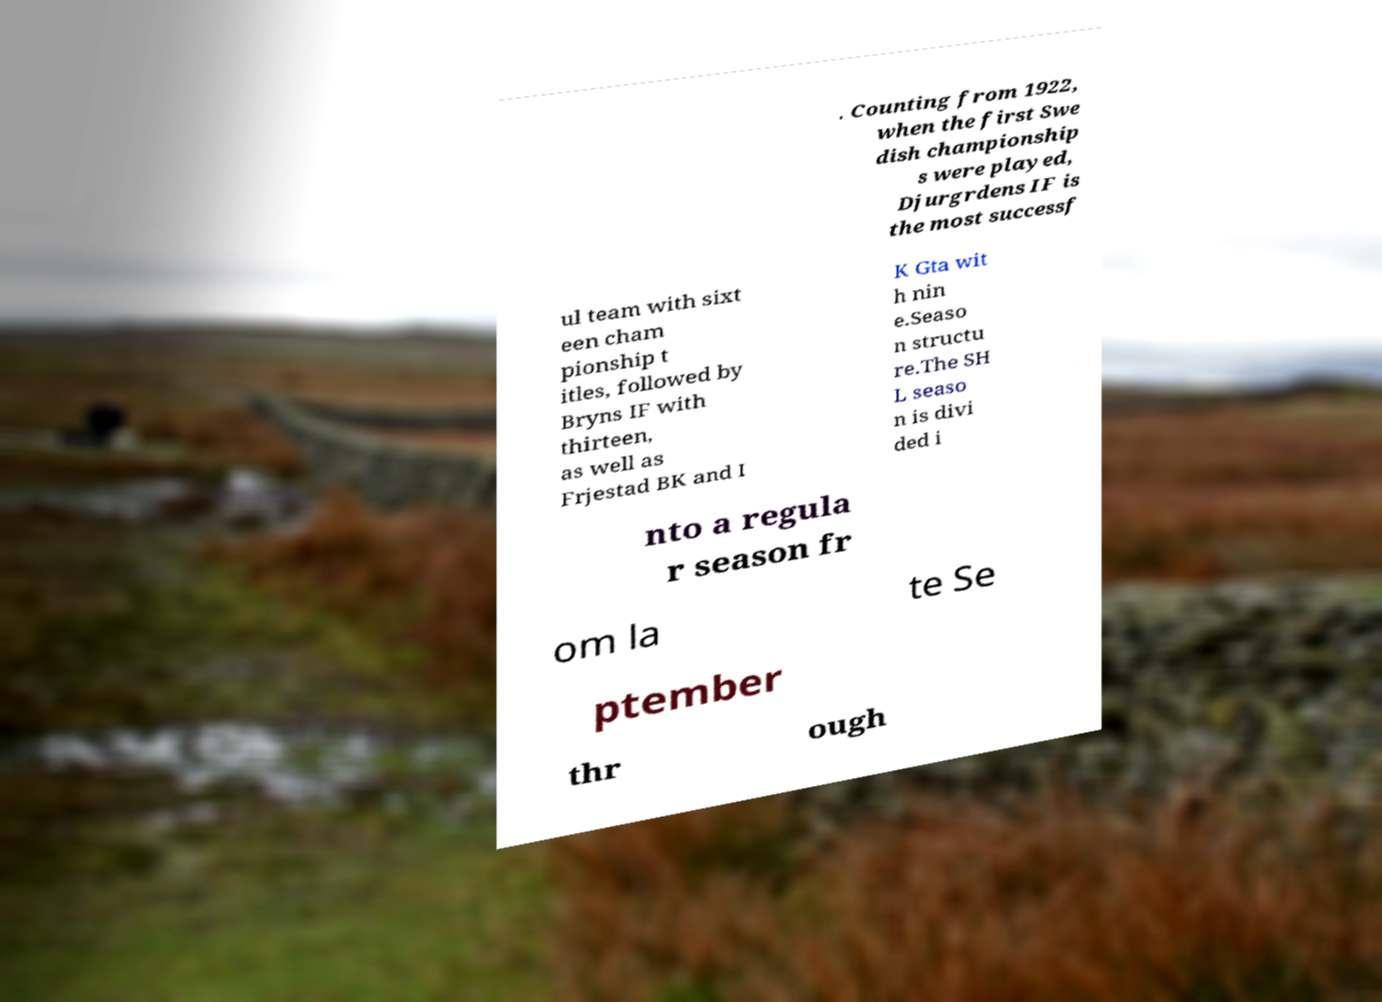Please read and relay the text visible in this image. What does it say? . Counting from 1922, when the first Swe dish championship s were played, Djurgrdens IF is the most successf ul team with sixt een cham pionship t itles, followed by Bryns IF with thirteen, as well as Frjestad BK and I K Gta wit h nin e.Seaso n structu re.The SH L seaso n is divi ded i nto a regula r season fr om la te Se ptember thr ough 